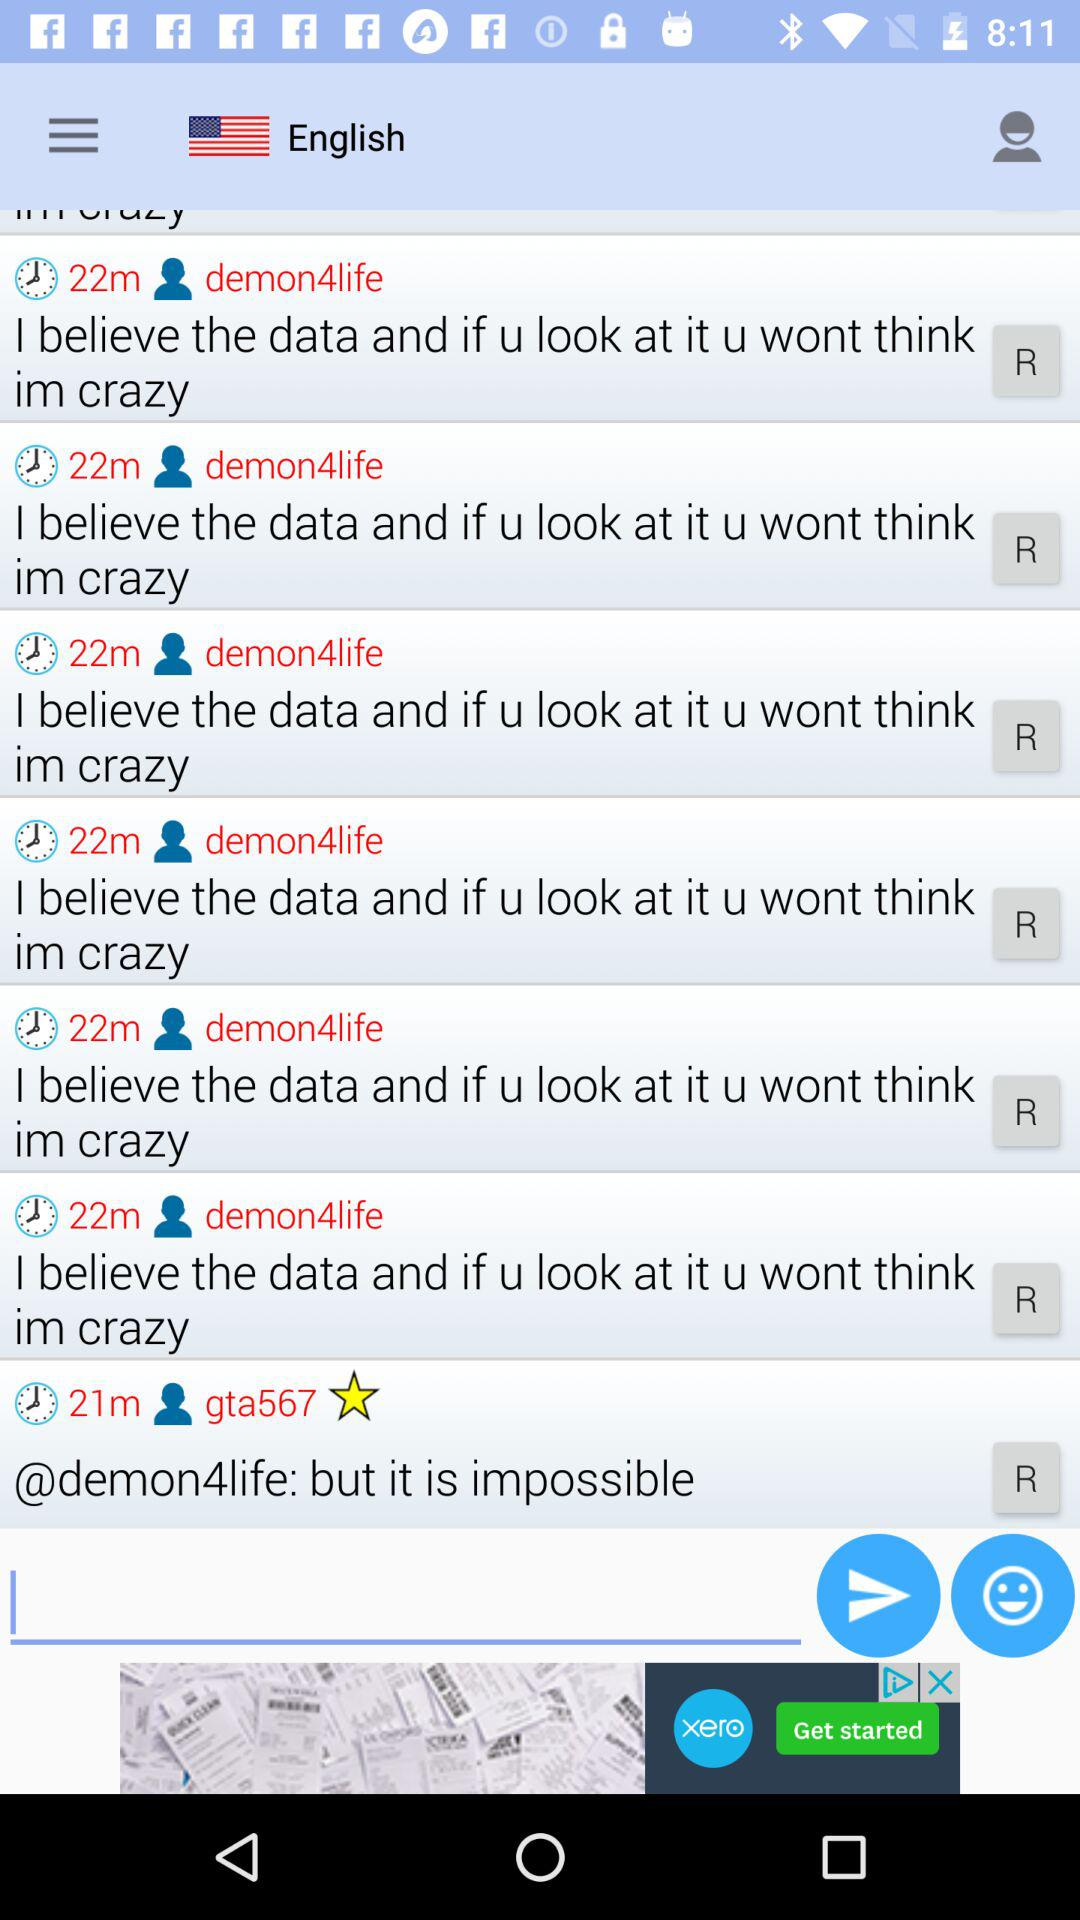How many minutes ago did "demon4life" post? "demon4life" posted 22 minutes ago. 